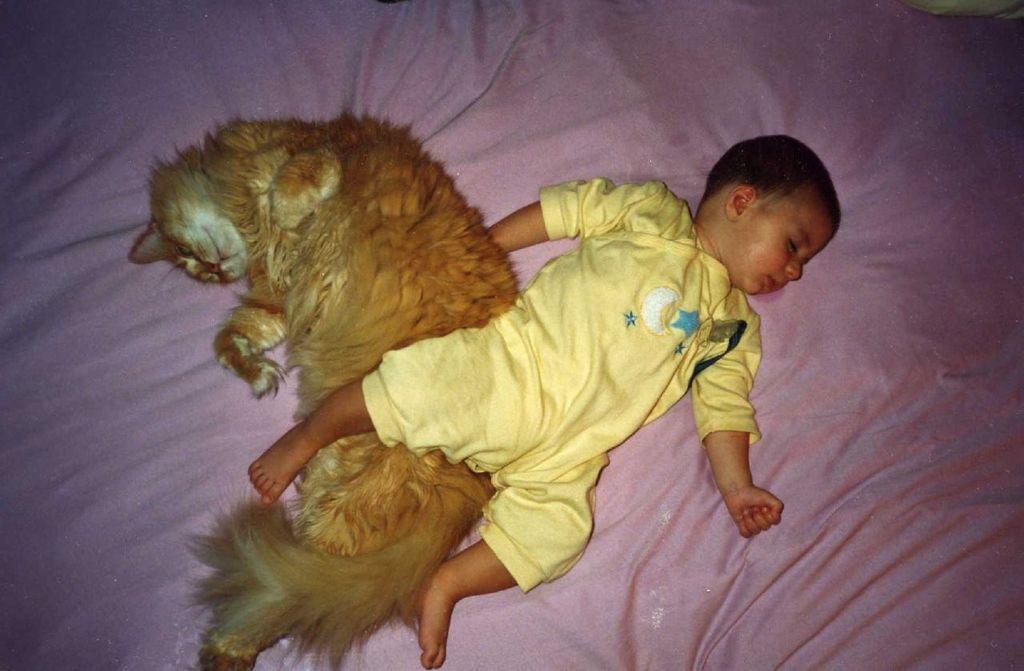Can you describe this image briefly? Here in this picture we can see a cat and a baby sleeping. Under the cat babies right hand is there, and left leg is on the cat. Baby is wearing a yellow color dress with moon and stars on it. They both are sleeping on the pick bed sheet. 